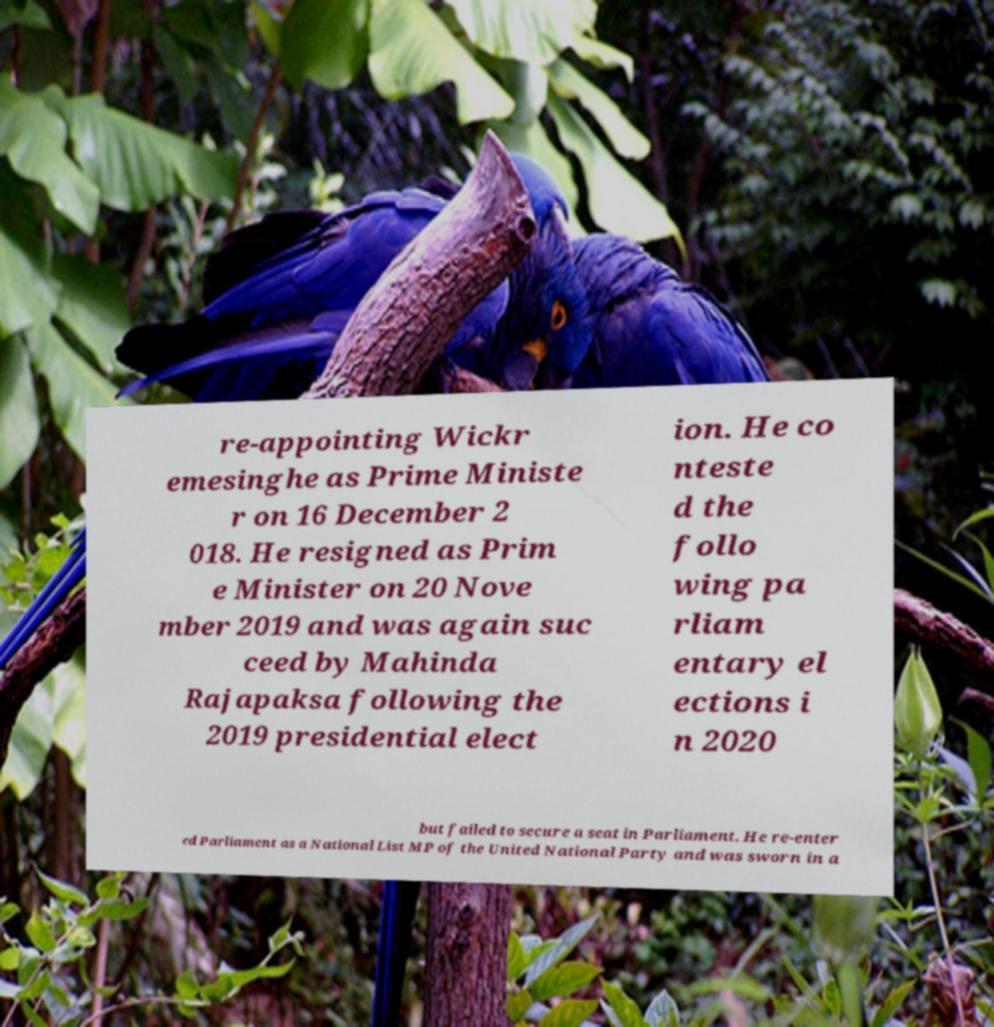For documentation purposes, I need the text within this image transcribed. Could you provide that? re-appointing Wickr emesinghe as Prime Ministe r on 16 December 2 018. He resigned as Prim e Minister on 20 Nove mber 2019 and was again suc ceed by Mahinda Rajapaksa following the 2019 presidential elect ion. He co nteste d the follo wing pa rliam entary el ections i n 2020 but failed to secure a seat in Parliament. He re-enter ed Parliament as a National List MP of the United National Party and was sworn in a 